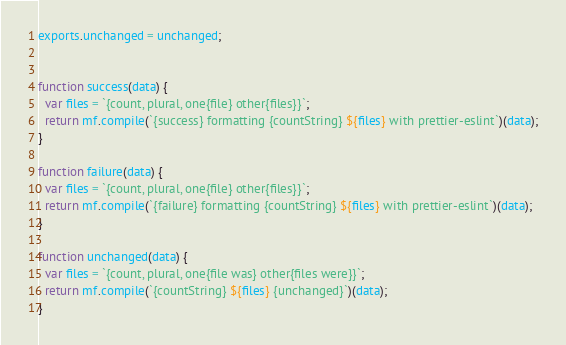Convert code to text. <code><loc_0><loc_0><loc_500><loc_500><_JavaScript_>exports.unchanged = unchanged;


function success(data) {
  var files = `{count, plural, one{file} other{files}}`;
  return mf.compile(`{success} formatting {countString} ${files} with prettier-eslint`)(data);
}

function failure(data) {
  var files = `{count, plural, one{file} other{files}}`;
  return mf.compile(`{failure} formatting {countString} ${files} with prettier-eslint`)(data);
}

function unchanged(data) {
  var files = `{count, plural, one{file was} other{files were}}`;
  return mf.compile(`{countString} ${files} {unchanged}`)(data);
}</code> 